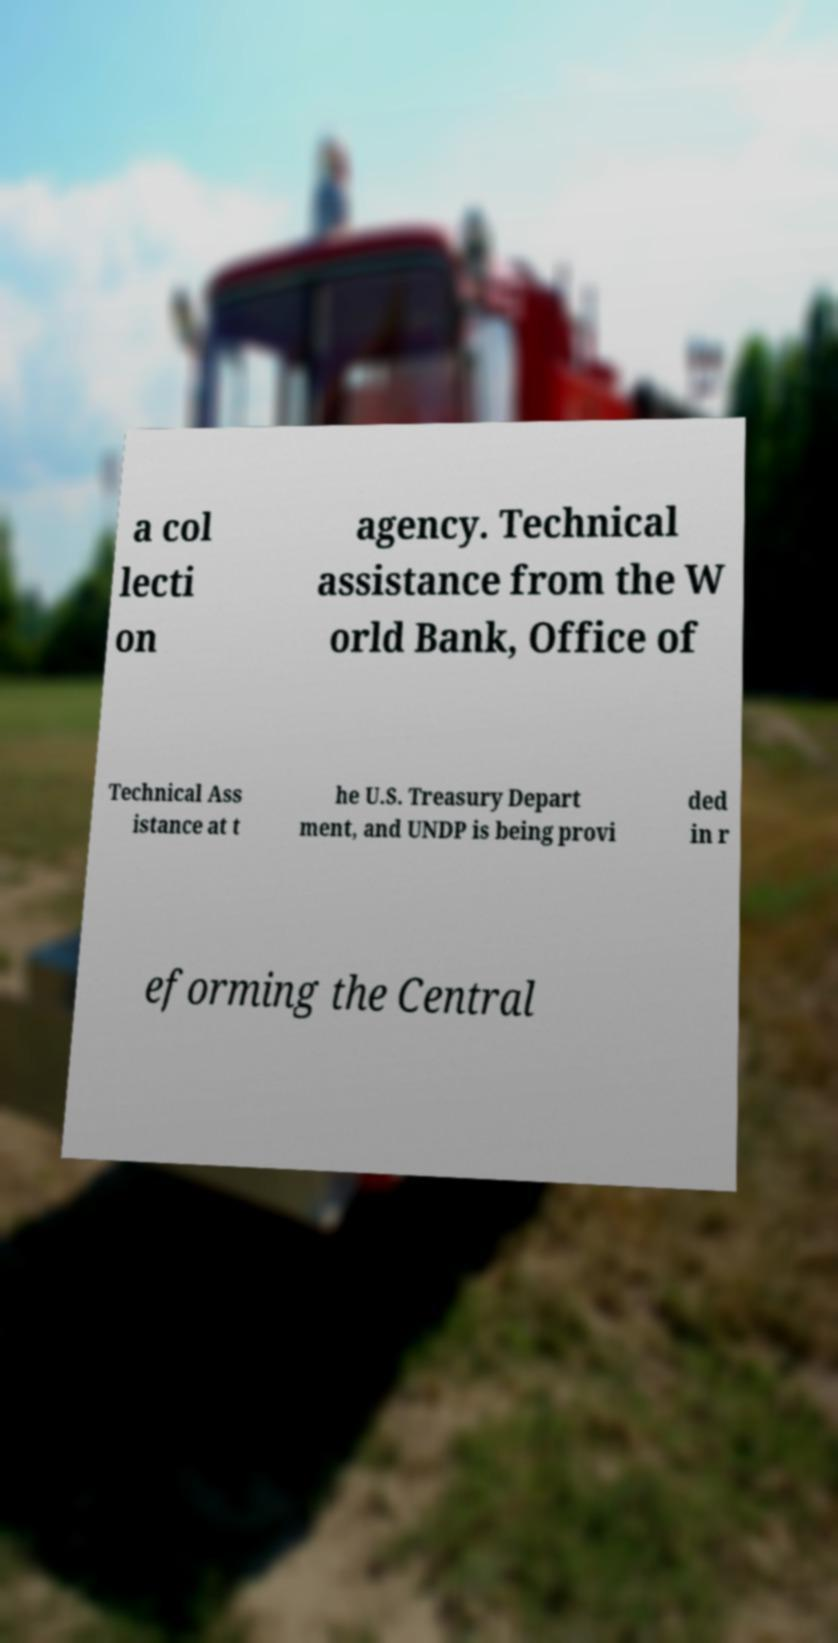Can you read and provide the text displayed in the image?This photo seems to have some interesting text. Can you extract and type it out for me? a col lecti on agency. Technical assistance from the W orld Bank, Office of Technical Ass istance at t he U.S. Treasury Depart ment, and UNDP is being provi ded in r eforming the Central 